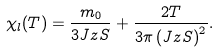<formula> <loc_0><loc_0><loc_500><loc_500>\chi _ { l } ( T ) = \frac { m _ { 0 } } { 3 J z S } + \frac { 2 T } { 3 \pi \left ( J z S \right ) ^ { 2 } } .</formula> 